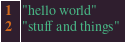<code> <loc_0><loc_0><loc_500><loc_500><_Scheme_>"hello world"
"stuff and things"
</code> 